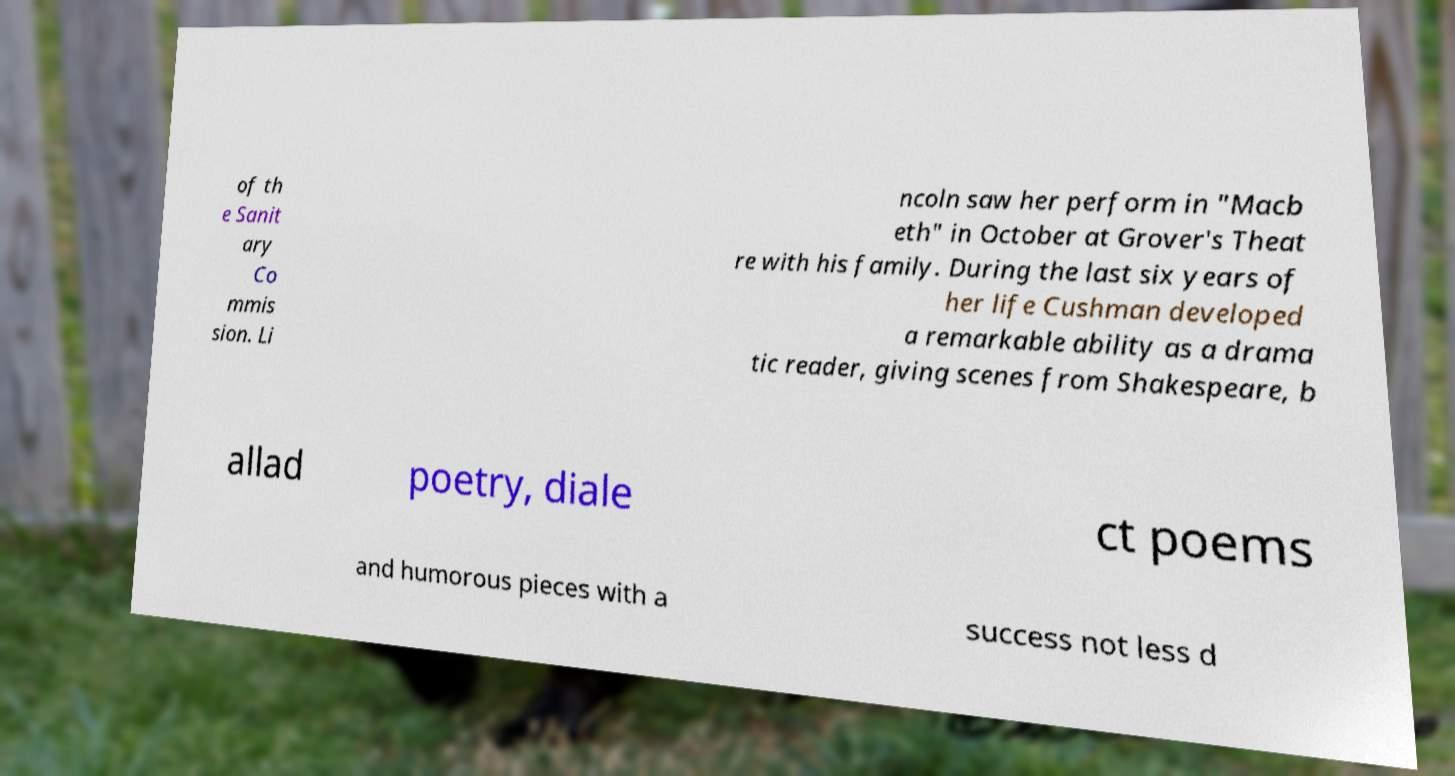Please identify and transcribe the text found in this image. of th e Sanit ary Co mmis sion. Li ncoln saw her perform in "Macb eth" in October at Grover's Theat re with his family. During the last six years of her life Cushman developed a remarkable ability as a drama tic reader, giving scenes from Shakespeare, b allad poetry, diale ct poems and humorous pieces with a success not less d 